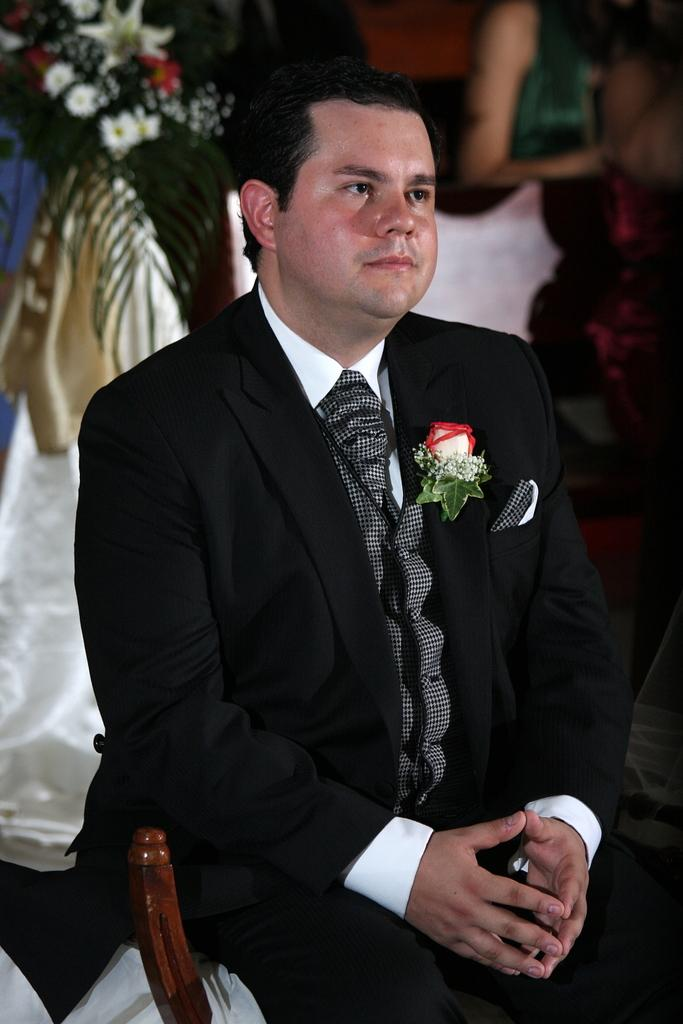What is the main subject of the image? There is a person wearing clothes in the image. What can be seen in the top left corner of the image? There are flowers in the top left of the image. Is there anyone else visible in the image? Yes, there is another person in the top right of the image. What type of silk is being used to create the route in the image? There is no silk or route present in the image. 